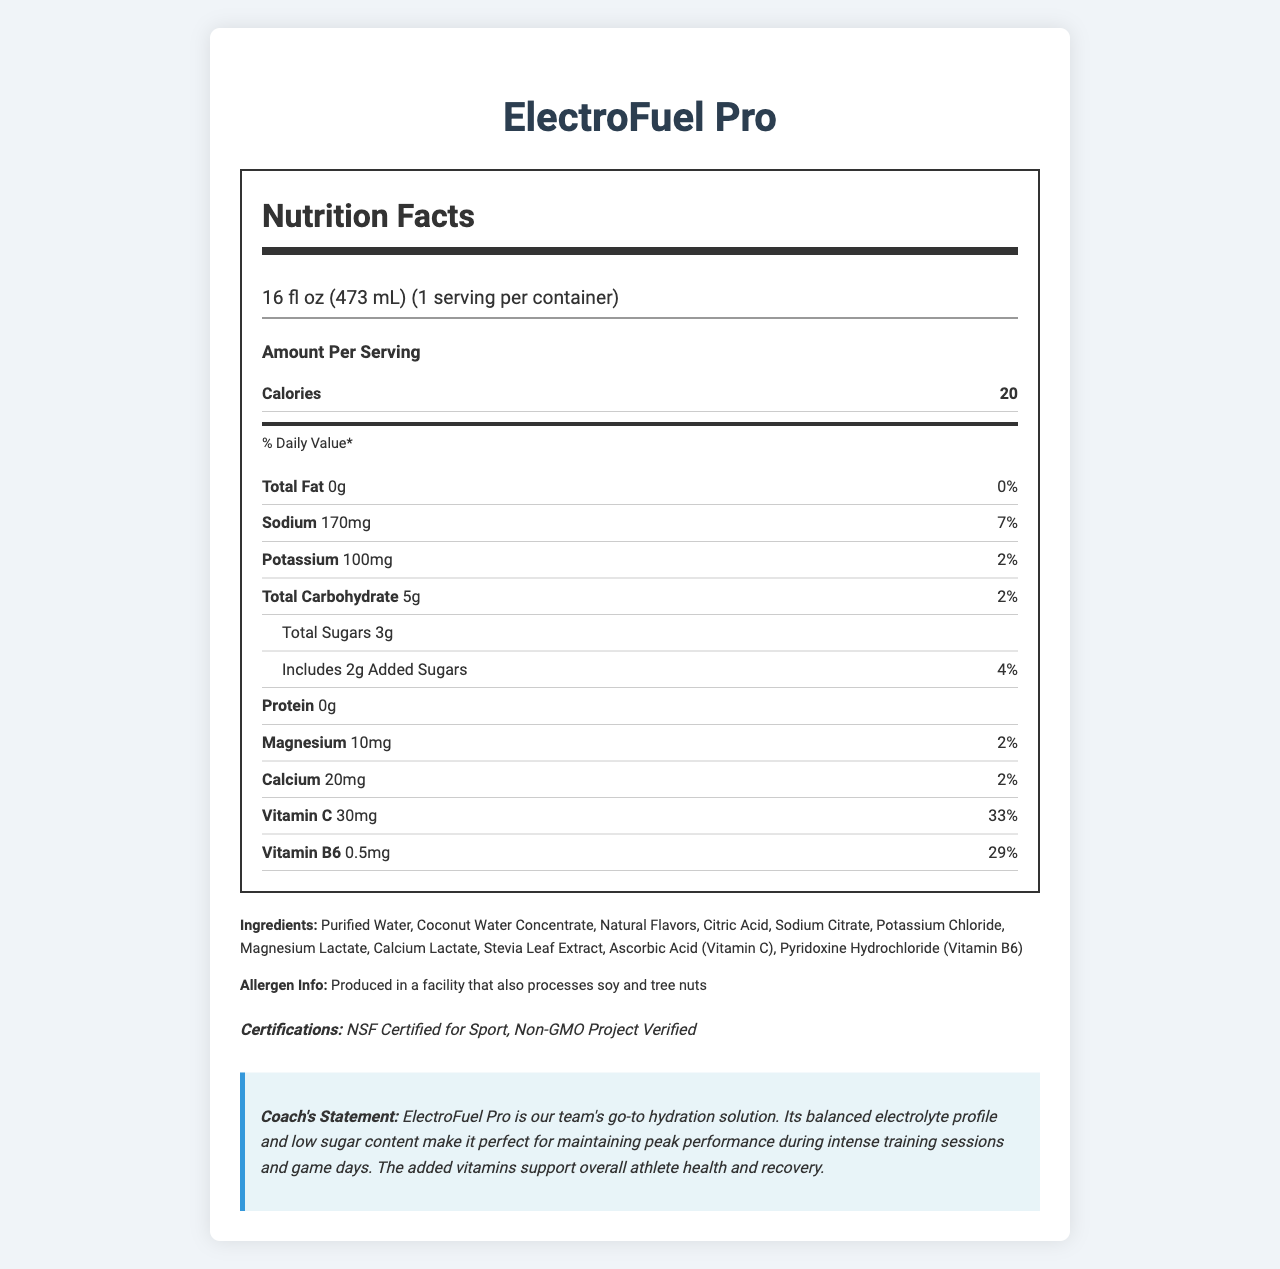what is the serving size of ElectroFuel Pro? The serving size is specified in the "serving size" field of the nutrition label.
Answer: 16 fl oz (473 mL) how many calories does one serving of ElectroFuel Pro contain? The number of calories per serving is listed under the "Amount Per Serving" heading.
Answer: 20 what is the daily value percentage of sodium in ElectroFuel Pro? The daily value percentage of sodium is noted next to its amount in the nutrition details.
Answer: 7% how much potassium is in one serving? The amount of potassium in one serving is given in the nutrient section.
Answer: 100mg how many grams of added sugars are in ElectroFuel Pro? The amount of added sugars is listed under the "total sugars" subsection.
Answer: 2g how much Vitamin C does ElectroFuel Pro provide per serving? A. 10mg B. 20mg C. 30mg D. 40mg The nutrient information section specifies that one serving provides 30mg of Vitamin C.
Answer: C what certifications does ElectroFuel Pro hold? A. NSF Certified for Sport B. Non-GMO Project Verified C. USDA Organic D. All of the above The document lists both "NSF Certified for Sport" and "Non-GMO Project Verified" as certifications held by ElectroFuel Pro.
Answer: D is ElectroFuel Pro completely free of calories? The document states that one serving contains 20 calories.
Answer: No summarize the main points of the nutrition facts and other information provided. The explanation covers the main details provided in the nutrition facts label, including calorie content, the amounts and daily values of key nutrients, notable ingredients, certifications, and the coach's endorsement.
Answer: ElectroFuel Pro is a hydration-focused beverage with balanced electrolytes and low sugar content. It offers 20 calories per serving with 0g of fat, 7% daily value of sodium (170mg), 100mg of potassium, 2% daily value of total carbohydrates (5g), and 3g of total sugars (including 2g of added sugars). It provides significant amounts of Vitamin C (33% DV) and Vitamin B6 (29% DV). The product includes ingredients such as purified water and coconut water concentrate. ElectroFuel Pro is NSF Certified for Sport and Non-GMO Project Verified. A coach's statement endorses its suitability for maintaining peak athlete performance. what is the facility's allergen information? The allergen information is stated clearly under the ingredients section.
Answer: Produced in a facility that also processes soy and tree nuts how does ElectroFuel Pro help athletes according to the coach's statement? The coach's statement at the bottom of the document highlights the benefits for athletes.
Answer: It maintains peak performance during intense training sessions and game days while supporting overall athlete health and recovery. is there any mention of Vitamin D content in the document? The document does not provide any information about Vitamin D content.
Answer: No what is the ingredient used as a sweetener in ElectroFuel Pro? The ingredient list includes Stevia Leaf Extract, which is commonly used as a natural sweetener.
Answer: Stevia Leaf Extract what is the purpose of Sodium Citrate in the list of ingredients? The document does not provide specific roles or purposes for the individual ingredients listed.
Answer: Cannot be determined 